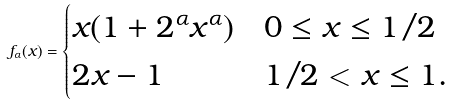<formula> <loc_0><loc_0><loc_500><loc_500>f _ { \alpha } ( x ) = \begin{cases} x ( 1 + 2 ^ { \alpha } x ^ { \alpha } ) & 0 \leq x \leq 1 / 2 \\ 2 x - 1 & 1 / 2 < x \leq 1 . \end{cases}</formula> 